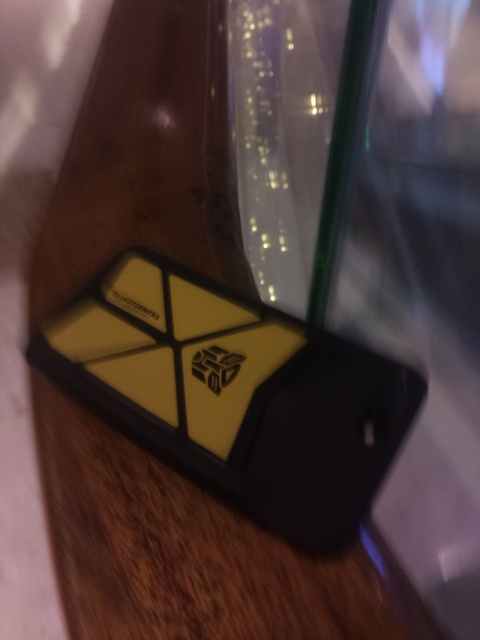Are the content in the image blurred? Yes, the content in the image is blurred, which hinders clear identification of the specific details. However, it seems to be a mobile phone case with a distinctive logo, perhaps alluding to a pop culture reference or a brand symbol. 